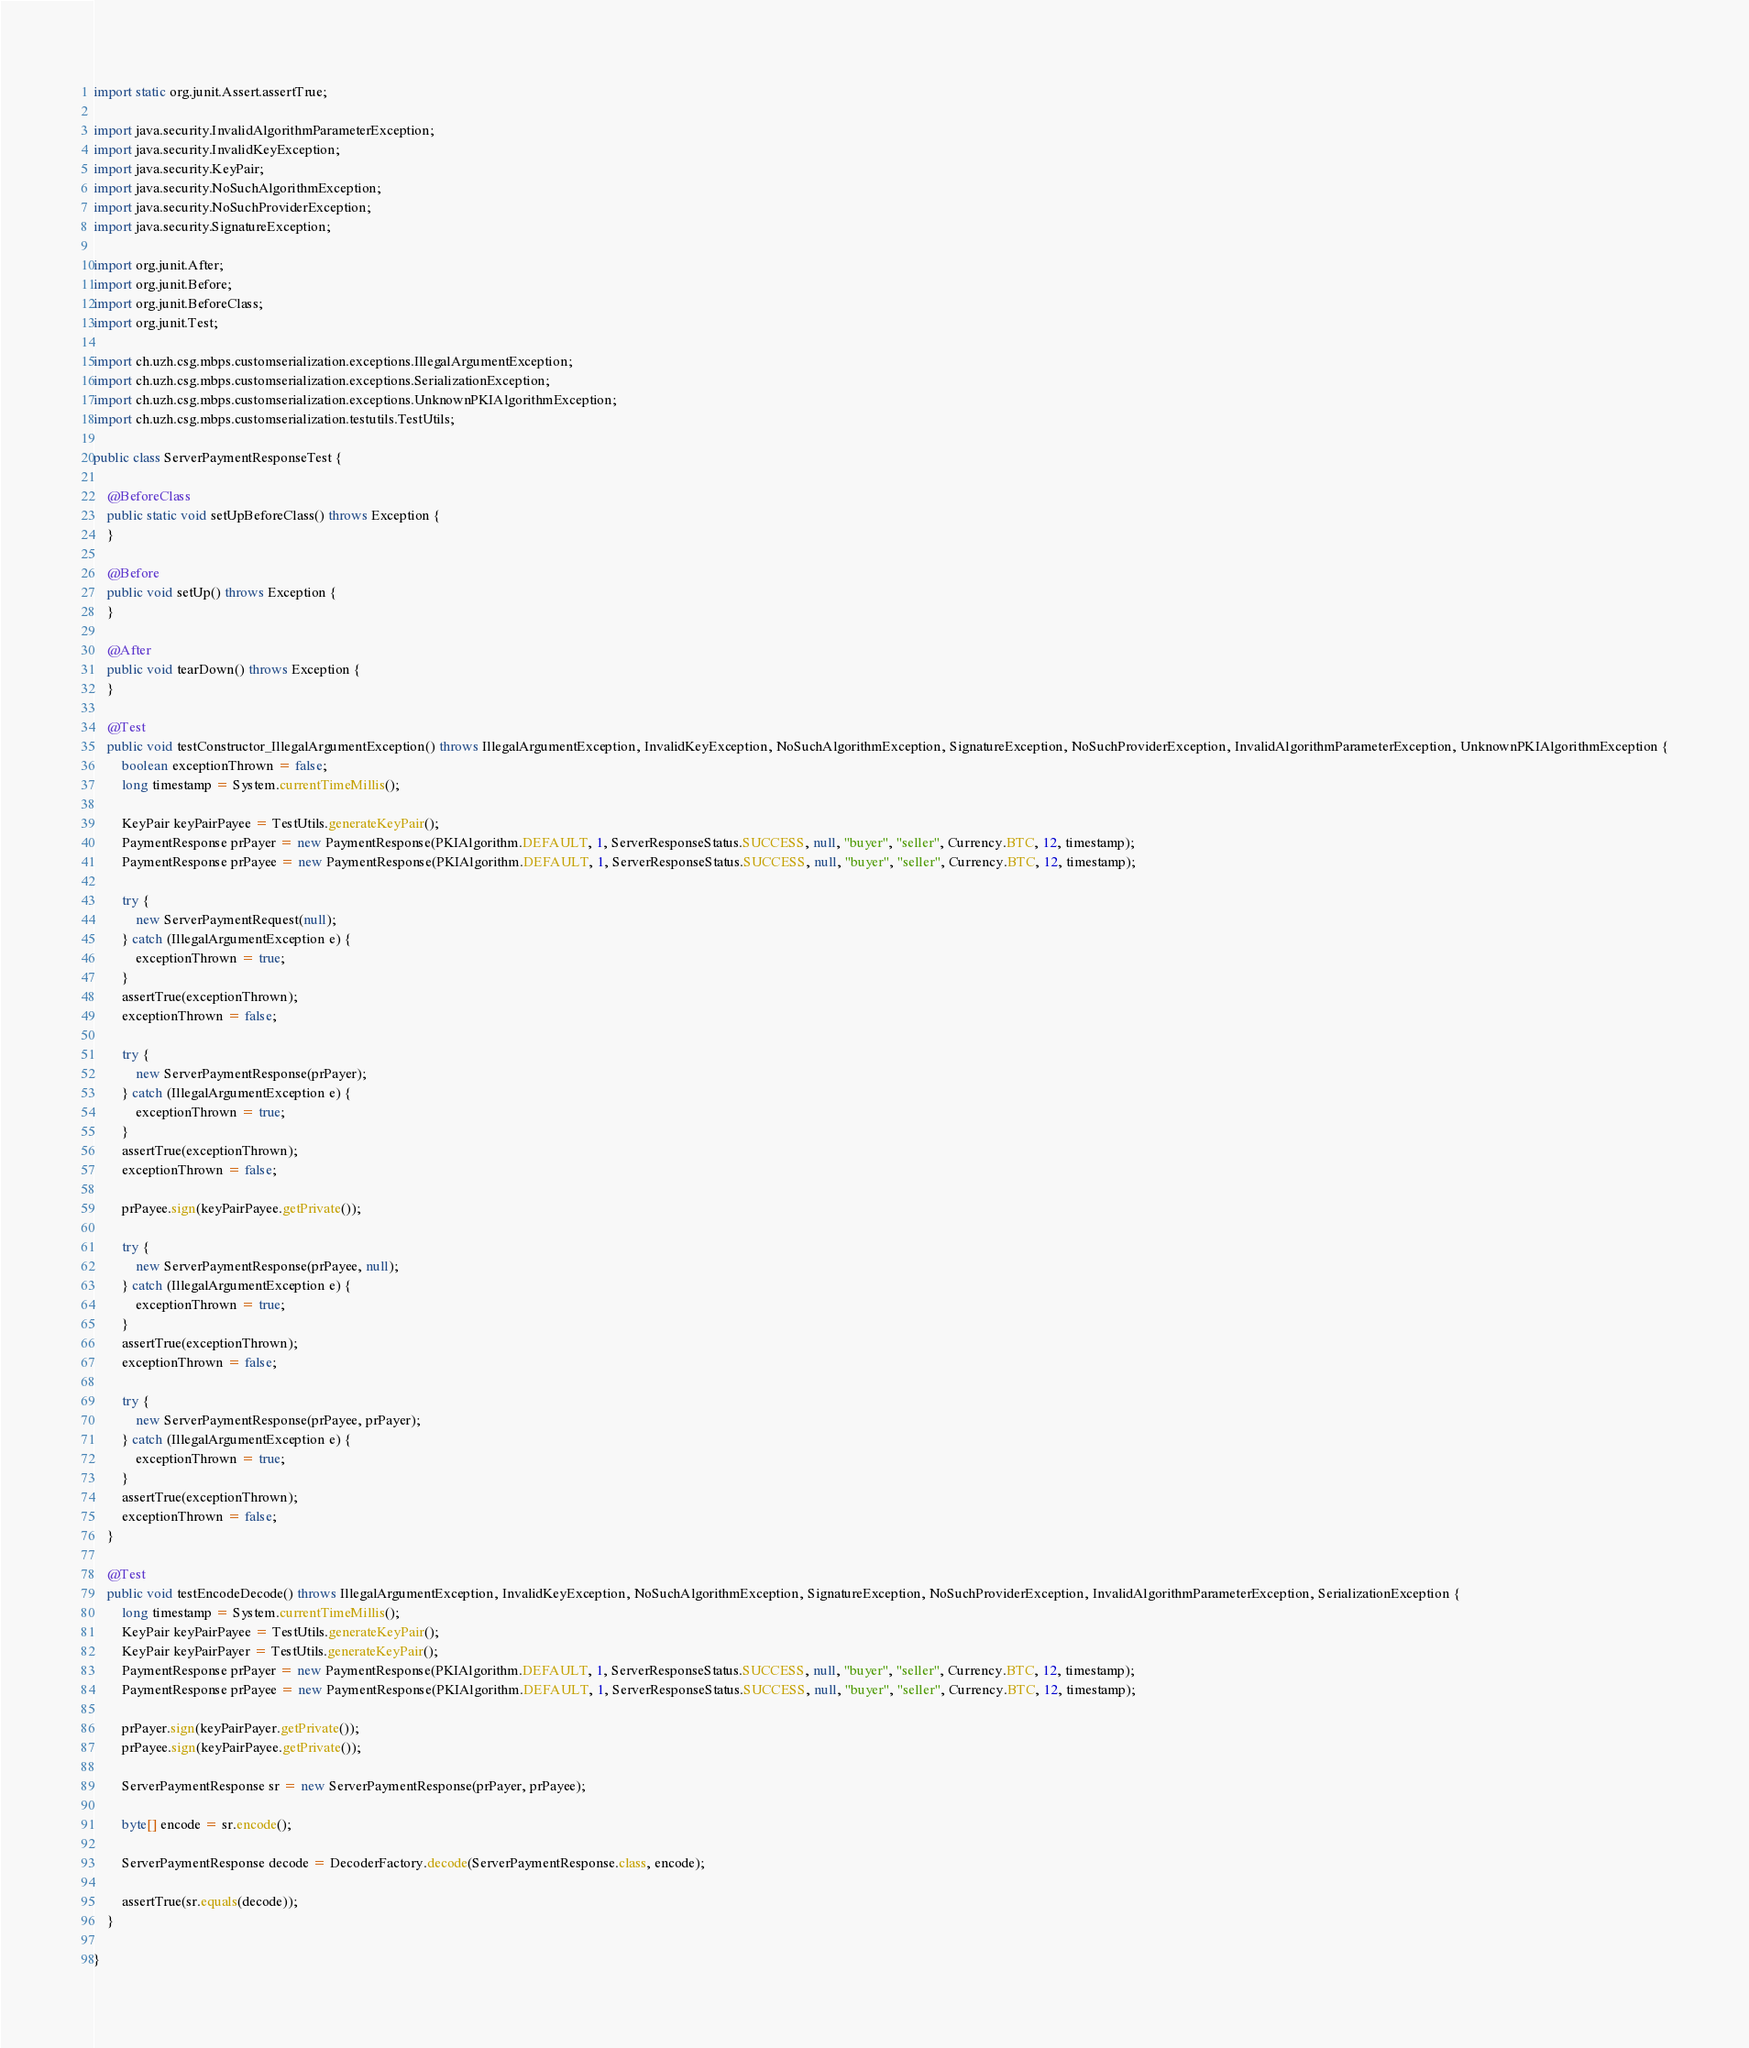<code> <loc_0><loc_0><loc_500><loc_500><_Java_>
import static org.junit.Assert.assertTrue;

import java.security.InvalidAlgorithmParameterException;
import java.security.InvalidKeyException;
import java.security.KeyPair;
import java.security.NoSuchAlgorithmException;
import java.security.NoSuchProviderException;
import java.security.SignatureException;

import org.junit.After;
import org.junit.Before;
import org.junit.BeforeClass;
import org.junit.Test;

import ch.uzh.csg.mbps.customserialization.exceptions.IllegalArgumentException;
import ch.uzh.csg.mbps.customserialization.exceptions.SerializationException;
import ch.uzh.csg.mbps.customserialization.exceptions.UnknownPKIAlgorithmException;
import ch.uzh.csg.mbps.customserialization.testutils.TestUtils;

public class ServerPaymentResponseTest {

	@BeforeClass
	public static void setUpBeforeClass() throws Exception {
	}

	@Before
	public void setUp() throws Exception {
	}

	@After
	public void tearDown() throws Exception {
	}

	@Test
	public void testConstructor_IllegalArgumentException() throws IllegalArgumentException, InvalidKeyException, NoSuchAlgorithmException, SignatureException, NoSuchProviderException, InvalidAlgorithmParameterException, UnknownPKIAlgorithmException {
		boolean exceptionThrown = false;
		long timestamp = System.currentTimeMillis();
		
		KeyPair keyPairPayee = TestUtils.generateKeyPair();
		PaymentResponse prPayer = new PaymentResponse(PKIAlgorithm.DEFAULT, 1, ServerResponseStatus.SUCCESS, null, "buyer", "seller", Currency.BTC, 12, timestamp);
		PaymentResponse prPayee = new PaymentResponse(PKIAlgorithm.DEFAULT, 1, ServerResponseStatus.SUCCESS, null, "buyer", "seller", Currency.BTC, 12, timestamp);
		
		try {
			new ServerPaymentRequest(null);
		} catch (IllegalArgumentException e) {
			exceptionThrown = true;
		}
		assertTrue(exceptionThrown);
		exceptionThrown = false;
		
		try {
			new ServerPaymentResponse(prPayer);
		} catch (IllegalArgumentException e) {
			exceptionThrown = true;
		}
		assertTrue(exceptionThrown);
		exceptionThrown = false;
		
		prPayee.sign(keyPairPayee.getPrivate());
		
		try {
			new ServerPaymentResponse(prPayee, null);
		} catch (IllegalArgumentException e) {
			exceptionThrown = true;
		}
		assertTrue(exceptionThrown);
		exceptionThrown = false;
		
		try {
			new ServerPaymentResponse(prPayee, prPayer);
		} catch (IllegalArgumentException e) {
			exceptionThrown = true;
		}
		assertTrue(exceptionThrown);
		exceptionThrown = false;
	}
	
	@Test
	public void testEncodeDecode() throws IllegalArgumentException, InvalidKeyException, NoSuchAlgorithmException, SignatureException, NoSuchProviderException, InvalidAlgorithmParameterException, SerializationException {
		long timestamp = System.currentTimeMillis();
		KeyPair keyPairPayee = TestUtils.generateKeyPair();
		KeyPair keyPairPayer = TestUtils.generateKeyPair();
		PaymentResponse prPayer = new PaymentResponse(PKIAlgorithm.DEFAULT, 1, ServerResponseStatus.SUCCESS, null, "buyer", "seller", Currency.BTC, 12, timestamp);
		PaymentResponse prPayee = new PaymentResponse(PKIAlgorithm.DEFAULT, 1, ServerResponseStatus.SUCCESS, null, "buyer", "seller", Currency.BTC, 12, timestamp);
		
		prPayer.sign(keyPairPayer.getPrivate());
		prPayee.sign(keyPairPayee.getPrivate());
		
		ServerPaymentResponse sr = new ServerPaymentResponse(prPayer, prPayee);
		
		byte[] encode = sr.encode();
		
		ServerPaymentResponse decode = DecoderFactory.decode(ServerPaymentResponse.class, encode);
		
		assertTrue(sr.equals(decode));
	}

}
</code> 